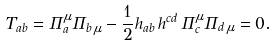Convert formula to latex. <formula><loc_0><loc_0><loc_500><loc_500>T _ { a b } = \Pi _ { a } ^ { \mu } \Pi _ { b \, \mu } - \frac { 1 } { 2 } h _ { a b } \, h ^ { c d } \, \Pi _ { c } ^ { \mu } \Pi _ { d \, \mu } = 0 .</formula> 